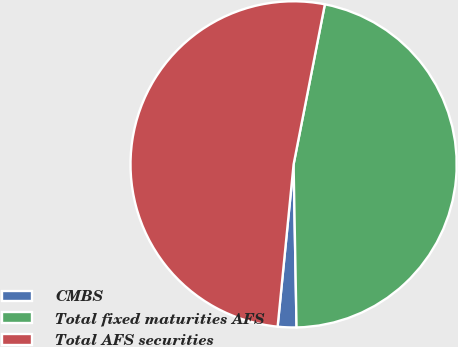<chart> <loc_0><loc_0><loc_500><loc_500><pie_chart><fcel>CMBS<fcel>Total fixed maturities AFS<fcel>Total AFS securities<nl><fcel>1.85%<fcel>46.64%<fcel>51.51%<nl></chart> 